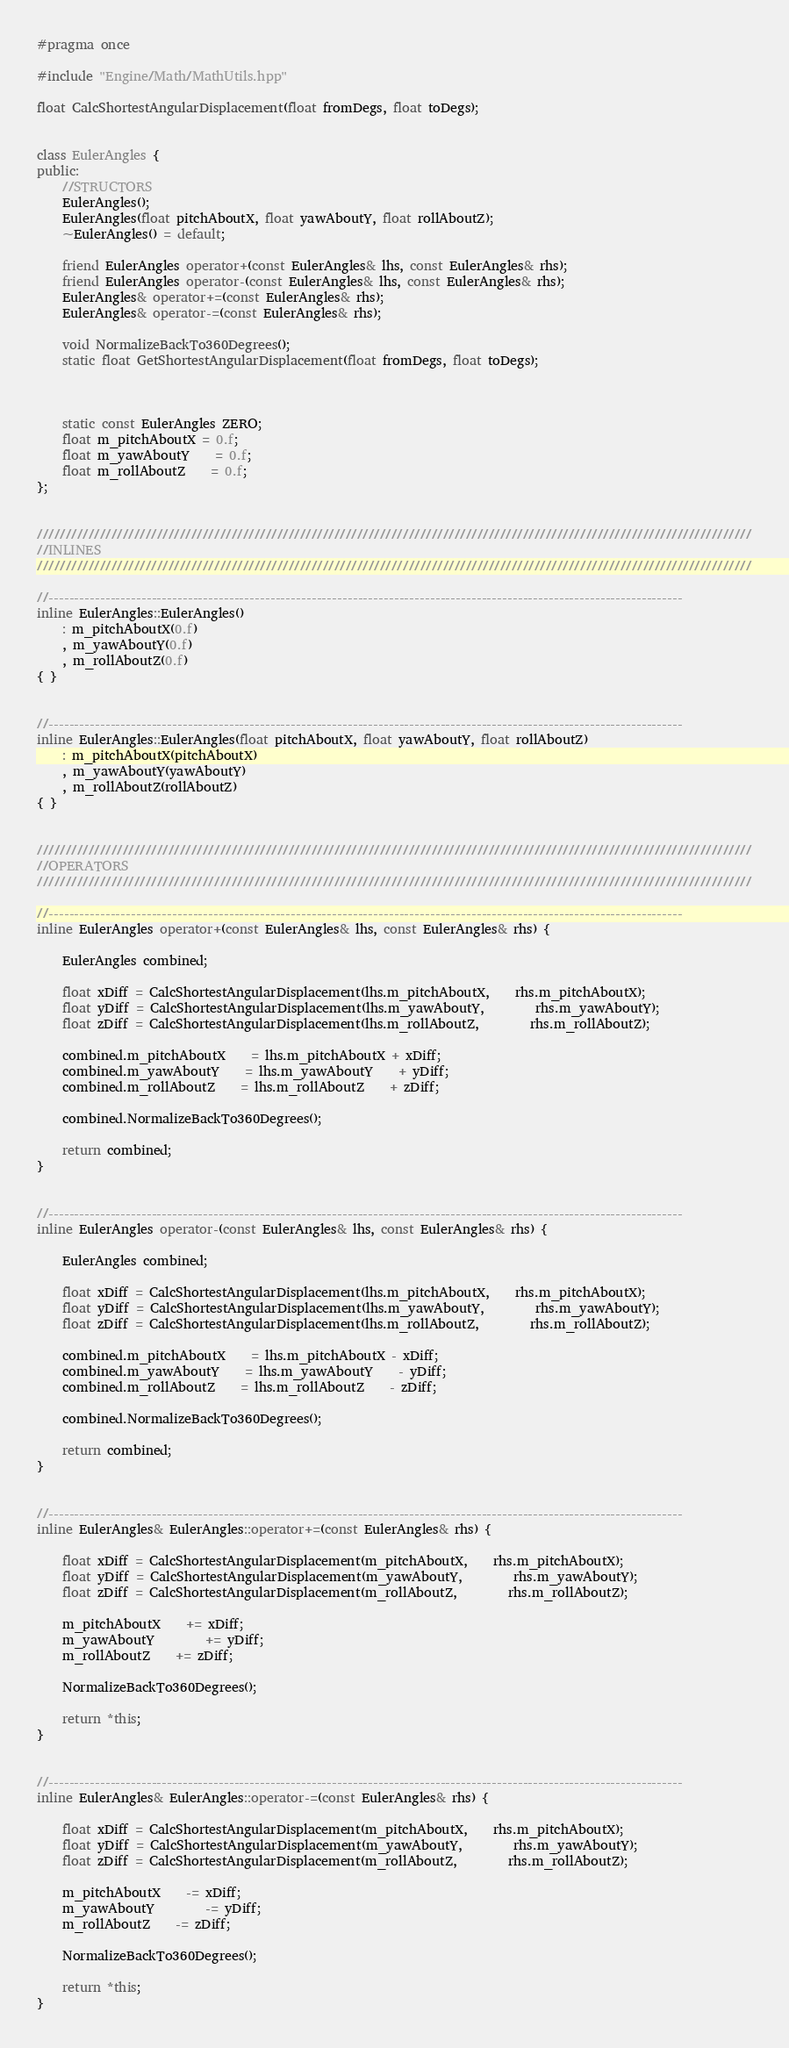<code> <loc_0><loc_0><loc_500><loc_500><_C++_>#pragma once

#include "Engine/Math/MathUtils.hpp"

float CalcShortestAngularDisplacement(float fromDegs, float toDegs);


class EulerAngles {
public:
	//STRUCTORS
	EulerAngles();
	EulerAngles(float pitchAboutX, float yawAboutY, float rollAboutZ);
	~EulerAngles() = default;

	friend EulerAngles operator+(const EulerAngles& lhs, const EulerAngles& rhs);
	friend EulerAngles operator-(const EulerAngles& lhs, const EulerAngles& rhs);
	EulerAngles& operator+=(const EulerAngles& rhs);
	EulerAngles& operator-=(const EulerAngles& rhs);

	void NormalizeBackTo360Degrees();
	static float GetShortestAngularDisplacement(float fromDegs, float toDegs);



	static const EulerAngles ZERO;
	float m_pitchAboutX = 0.f;
	float m_yawAboutY	= 0.f;
	float m_rollAboutZ	= 0.f;
};


/////////////////////////////////////////////////////////////////////////////////////////////////////////////////////////////
//INLINES
/////////////////////////////////////////////////////////////////////////////////////////////////////////////////////////////

//---------------------------------------------------------------------------------------------------------------------------
inline EulerAngles::EulerAngles()
	: m_pitchAboutX(0.f)
	, m_yawAboutY(0.f)
	, m_rollAboutZ(0.f)
{ }


//---------------------------------------------------------------------------------------------------------------------------
inline EulerAngles::EulerAngles(float pitchAboutX, float yawAboutY, float rollAboutZ)
	: m_pitchAboutX(pitchAboutX)
	, m_yawAboutY(yawAboutY)
	, m_rollAboutZ(rollAboutZ)
{ }


/////////////////////////////////////////////////////////////////////////////////////////////////////////////////////////////
//OPERATORS
/////////////////////////////////////////////////////////////////////////////////////////////////////////////////////////////

//---------------------------------------------------------------------------------------------------------------------------
inline EulerAngles operator+(const EulerAngles& lhs, const EulerAngles& rhs) {

	EulerAngles combined;

	float xDiff = CalcShortestAngularDisplacement(lhs.m_pitchAboutX,	rhs.m_pitchAboutX);
	float yDiff = CalcShortestAngularDisplacement(lhs.m_yawAboutY,		rhs.m_yawAboutY);
	float zDiff = CalcShortestAngularDisplacement(lhs.m_rollAboutZ,		rhs.m_rollAboutZ);

	combined.m_pitchAboutX	= lhs.m_pitchAboutX + xDiff;
	combined.m_yawAboutY	= lhs.m_yawAboutY	+ yDiff;
	combined.m_rollAboutZ	= lhs.m_rollAboutZ	+ zDiff;

	combined.NormalizeBackTo360Degrees();

	return combined;
}


//---------------------------------------------------------------------------------------------------------------------------
inline EulerAngles operator-(const EulerAngles& lhs, const EulerAngles& rhs) {

	EulerAngles combined;

	float xDiff = CalcShortestAngularDisplacement(lhs.m_pitchAboutX,	rhs.m_pitchAboutX);
	float yDiff = CalcShortestAngularDisplacement(lhs.m_yawAboutY,		rhs.m_yawAboutY);
	float zDiff = CalcShortestAngularDisplacement(lhs.m_rollAboutZ,		rhs.m_rollAboutZ);
	 
	combined.m_pitchAboutX	= lhs.m_pitchAboutX - xDiff;
	combined.m_yawAboutY	= lhs.m_yawAboutY	- yDiff;
	combined.m_rollAboutZ	= lhs.m_rollAboutZ	- zDiff;

	combined.NormalizeBackTo360Degrees();

	return combined;
}


//---------------------------------------------------------------------------------------------------------------------------
inline EulerAngles& EulerAngles::operator+=(const EulerAngles& rhs) {

	float xDiff = CalcShortestAngularDisplacement(m_pitchAboutX,	rhs.m_pitchAboutX);
	float yDiff = CalcShortestAngularDisplacement(m_yawAboutY,		rhs.m_yawAboutY);
	float zDiff = CalcShortestAngularDisplacement(m_rollAboutZ,		rhs.m_rollAboutZ);

	m_pitchAboutX	+= xDiff;
	m_yawAboutY		+= yDiff;
	m_rollAboutZ	+= zDiff;

	NormalizeBackTo360Degrees();

	return *this;
}


//---------------------------------------------------------------------------------------------------------------------------
inline EulerAngles& EulerAngles::operator-=(const EulerAngles& rhs) {

	float xDiff = CalcShortestAngularDisplacement(m_pitchAboutX,	rhs.m_pitchAboutX);
	float yDiff = CalcShortestAngularDisplacement(m_yawAboutY,		rhs.m_yawAboutY);
	float zDiff = CalcShortestAngularDisplacement(m_rollAboutZ,		rhs.m_rollAboutZ);

	m_pitchAboutX	-= xDiff;
	m_yawAboutY		-= yDiff;
	m_rollAboutZ	-= zDiff;

	NormalizeBackTo360Degrees();

	return *this;
}</code> 